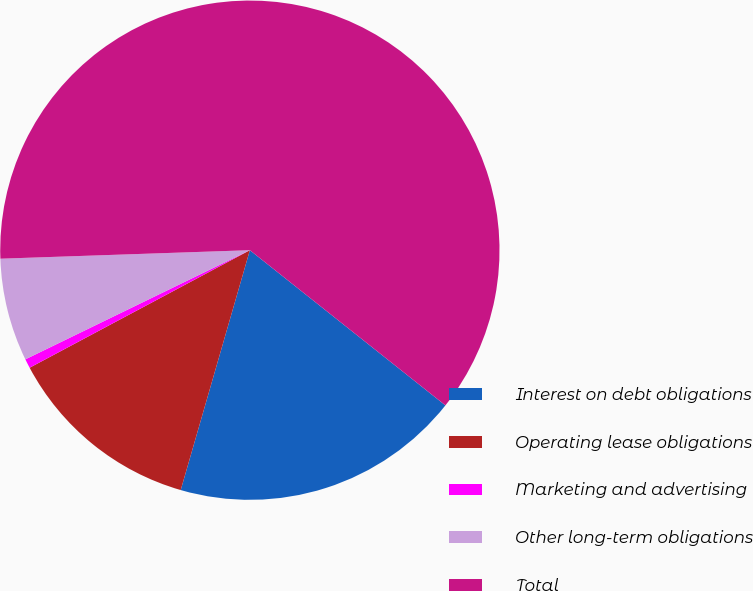Convert chart to OTSL. <chart><loc_0><loc_0><loc_500><loc_500><pie_chart><fcel>Interest on debt obligations<fcel>Operating lease obligations<fcel>Marketing and advertising<fcel>Other long-term obligations<fcel>Total<nl><fcel>18.79%<fcel>12.73%<fcel>0.6%<fcel>6.66%<fcel>61.22%<nl></chart> 